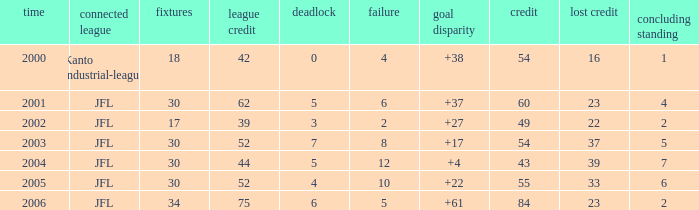Tell me the average final rank for loe more than 10 and point less than 43 None. 